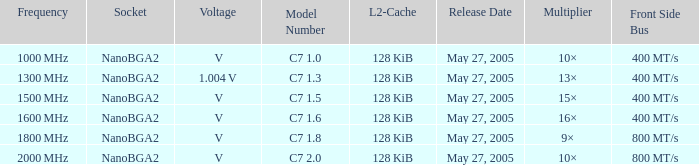What is the Front Side Bus for Model Number c7 1.5? 400 MT/s. 